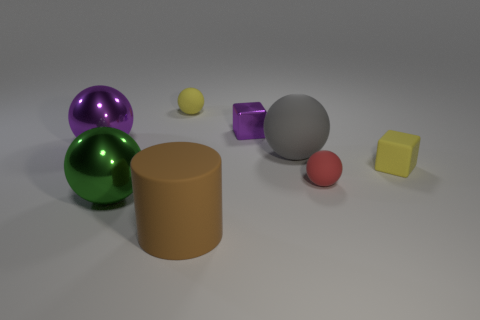Do the green sphere and the metallic block have the same size? No, the green sphere appears larger than the metallic block. The sphere has a prominent presence due to its reflective surface and color, which makes it stand out, while the metallic block, despite its shiny surface, is of a smaller size in comparison. 